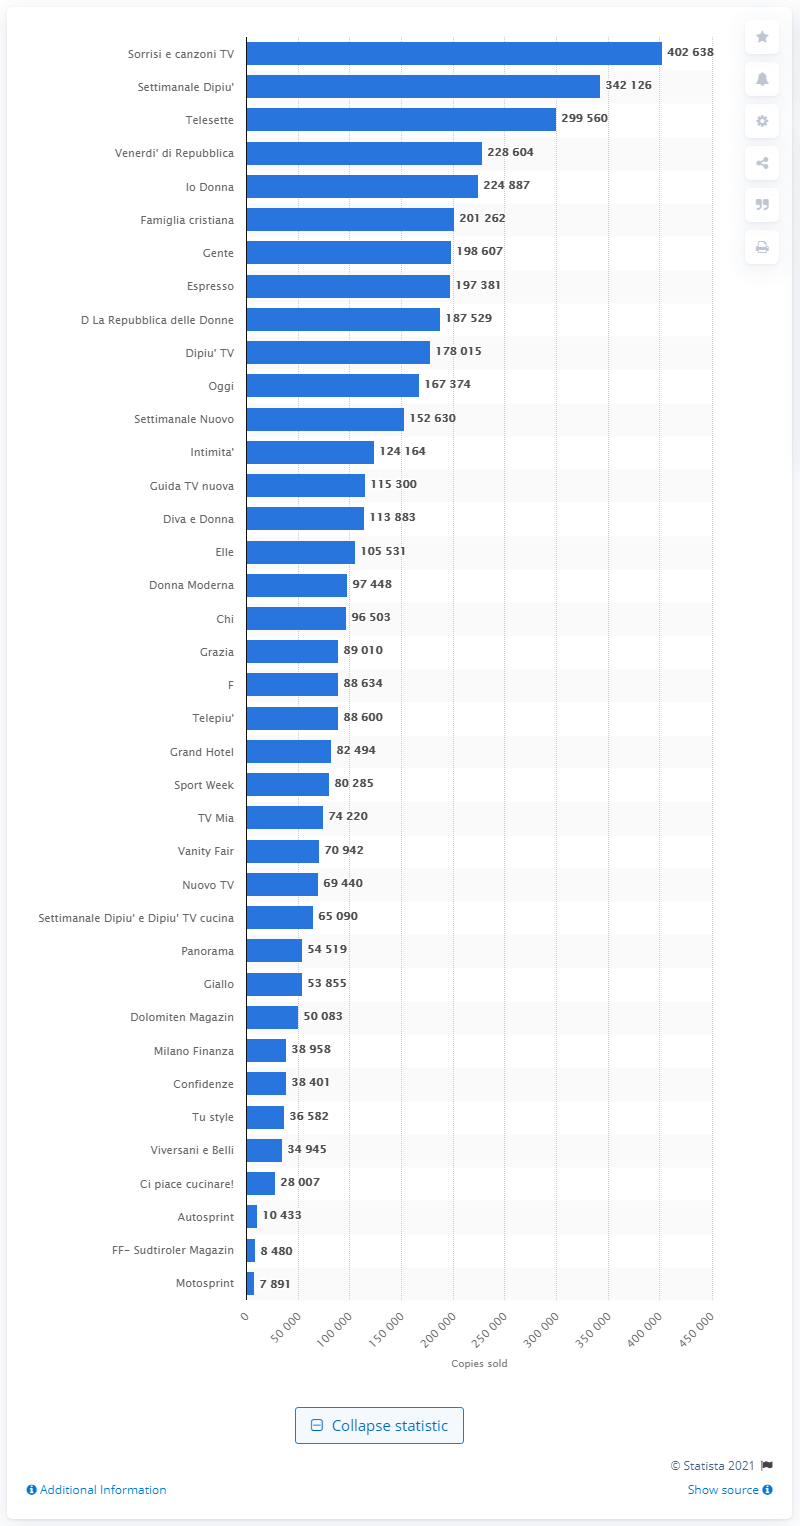Mention a couple of crucial points in this snapshot. Telesette is the third most popular Italian magazine. The total number of copies sold for Settimanale Di Pi1 was 342,126... As of December 2020, the number of copies of TV Sorrisi e Canzoni was 402,638. 